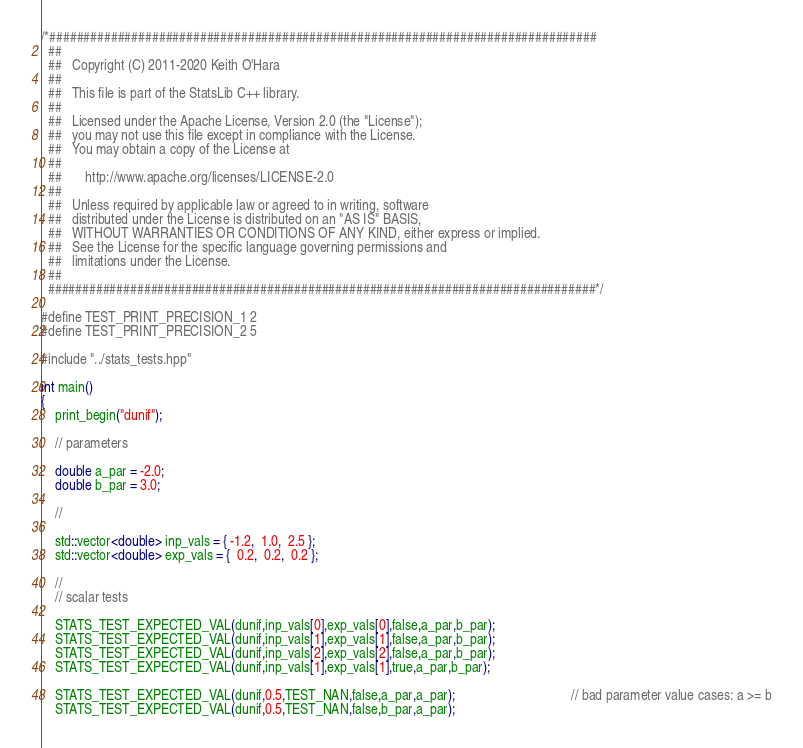<code> <loc_0><loc_0><loc_500><loc_500><_C++_>/*################################################################################
  ##
  ##   Copyright (C) 2011-2020 Keith O'Hara
  ##
  ##   This file is part of the StatsLib C++ library.
  ##
  ##   Licensed under the Apache License, Version 2.0 (the "License");
  ##   you may not use this file except in compliance with the License.
  ##   You may obtain a copy of the License at
  ##
  ##       http://www.apache.org/licenses/LICENSE-2.0
  ##
  ##   Unless required by applicable law or agreed to in writing, software
  ##   distributed under the License is distributed on an "AS IS" BASIS,
  ##   WITHOUT WARRANTIES OR CONDITIONS OF ANY KIND, either express or implied.
  ##   See the License for the specific language governing permissions and
  ##   limitations under the License.
  ##
  ################################################################################*/

#define TEST_PRINT_PRECISION_1 2
#define TEST_PRINT_PRECISION_2 5

#include "../stats_tests.hpp"

int main()
{
    print_begin("dunif");

    // parameters

    double a_par = -2.0;
    double b_par = 3.0;

    //

    std::vector<double> inp_vals = { -1.2,  1.0,  2.5 };
    std::vector<double> exp_vals = {  0.2,  0.2,  0.2 };

    //
    // scalar tests

    STATS_TEST_EXPECTED_VAL(dunif,inp_vals[0],exp_vals[0],false,a_par,b_par);
    STATS_TEST_EXPECTED_VAL(dunif,inp_vals[1],exp_vals[1],false,a_par,b_par);
    STATS_TEST_EXPECTED_VAL(dunif,inp_vals[2],exp_vals[2],false,a_par,b_par);
    STATS_TEST_EXPECTED_VAL(dunif,inp_vals[1],exp_vals[1],true,a_par,b_par);

    STATS_TEST_EXPECTED_VAL(dunif,0.5,TEST_NAN,false,a_par,a_par);                                  // bad parameter value cases: a >= b
    STATS_TEST_EXPECTED_VAL(dunif,0.5,TEST_NAN,false,b_par,a_par);
</code> 